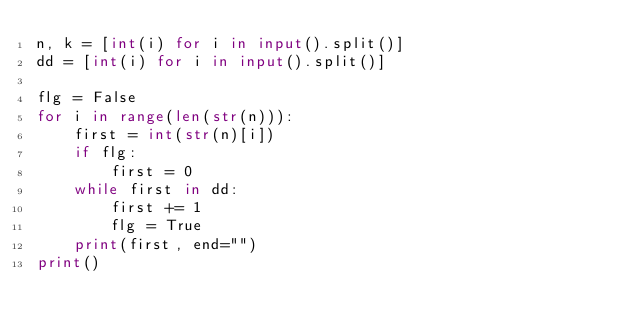Convert code to text. <code><loc_0><loc_0><loc_500><loc_500><_Python_>n, k = [int(i) for i in input().split()]
dd = [int(i) for i in input().split()]

flg = False
for i in range(len(str(n))):
    first = int(str(n)[i])
    if flg:
        first = 0
    while first in dd:
        first += 1
        flg = True
    print(first, end="")
print()
</code> 